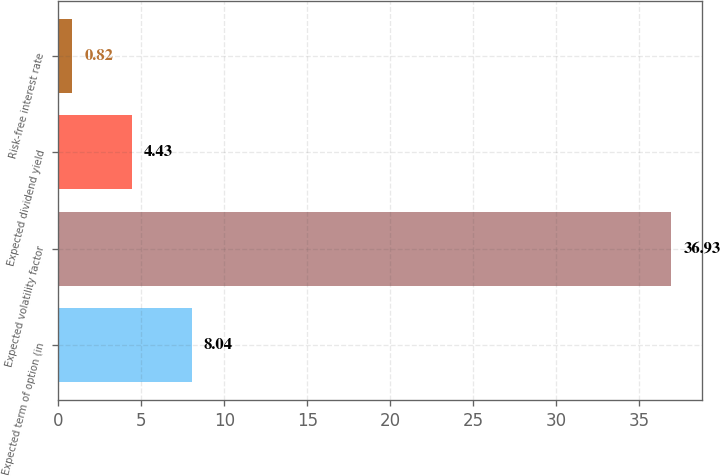Convert chart. <chart><loc_0><loc_0><loc_500><loc_500><bar_chart><fcel>Expected term of option (in<fcel>Expected volatility factor<fcel>Expected dividend yield<fcel>Risk-free interest rate<nl><fcel>8.04<fcel>36.93<fcel>4.43<fcel>0.82<nl></chart> 